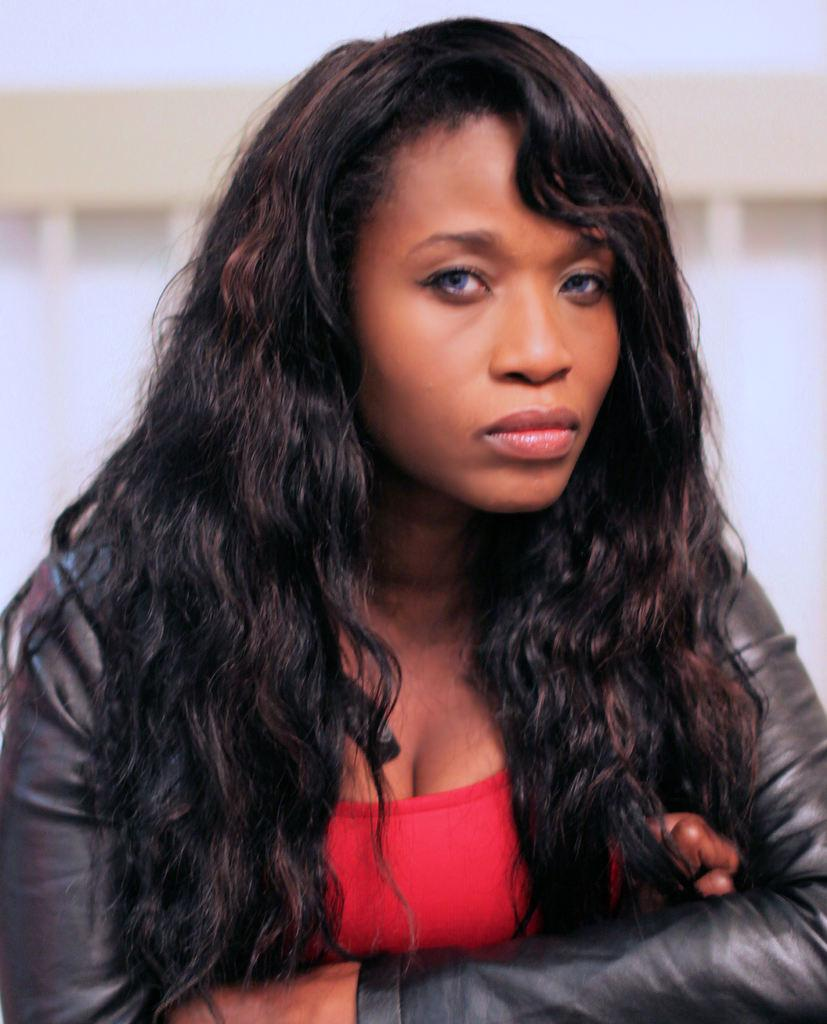Who is present in the image? There is a lady in the image. What is the lady wearing? The lady is wearing a red and black color dress. What type of boats can be seen in the image? There are no boats present in the image; it only features a lady wearing a red and black color dress. 